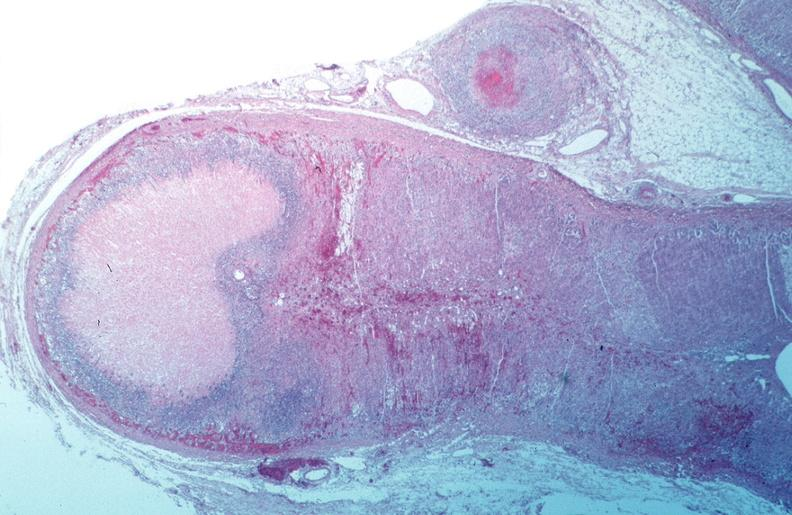what is present?
Answer the question using a single word or phrase. Vasculature 